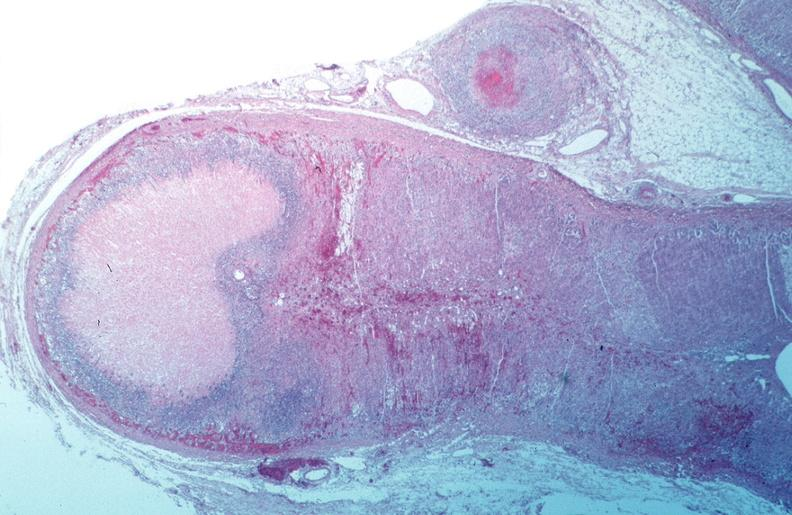what is present?
Answer the question using a single word or phrase. Vasculature 